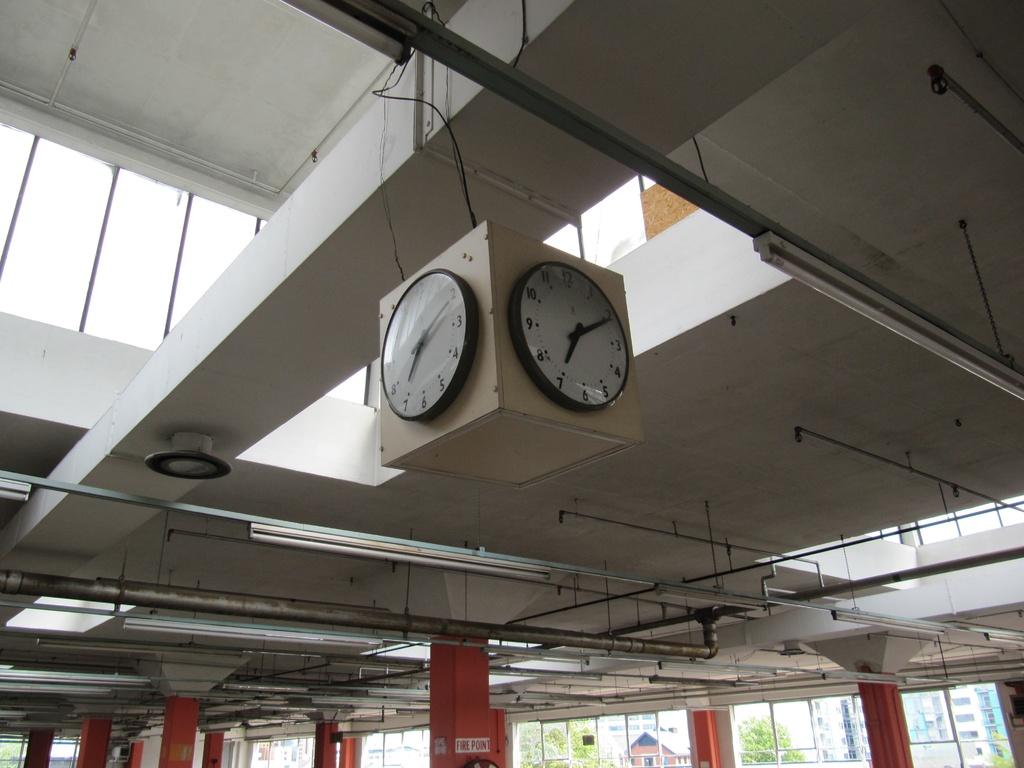What time is it?
Provide a short and direct response. 7:10. 